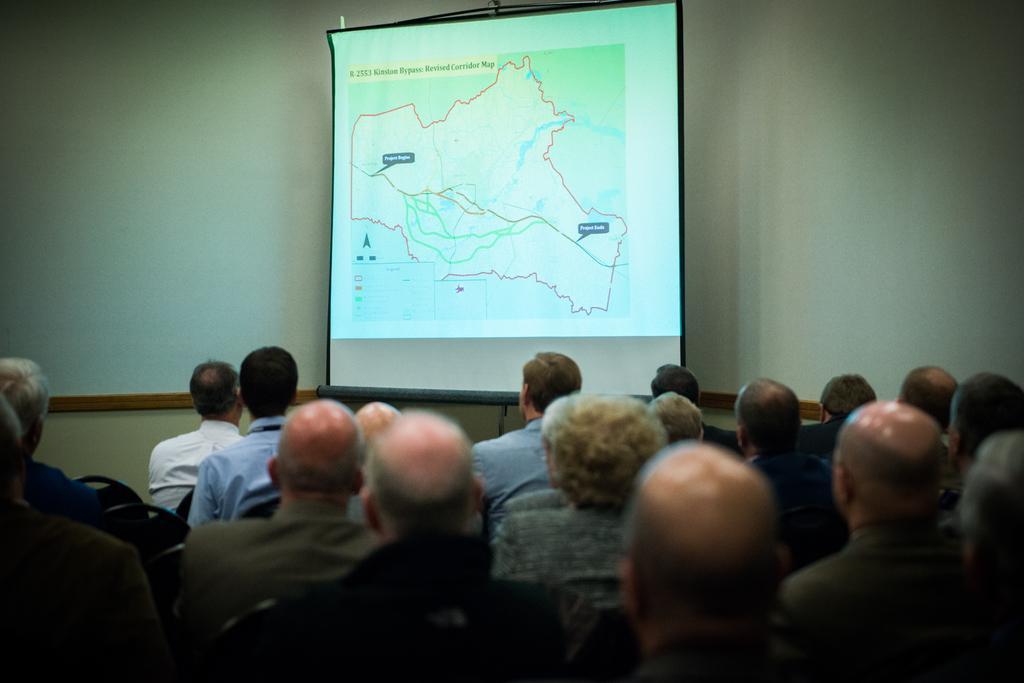Can you describe this image briefly? In this image I can see at the bottom a group of people are sitting, at the top there is the projector screen. 